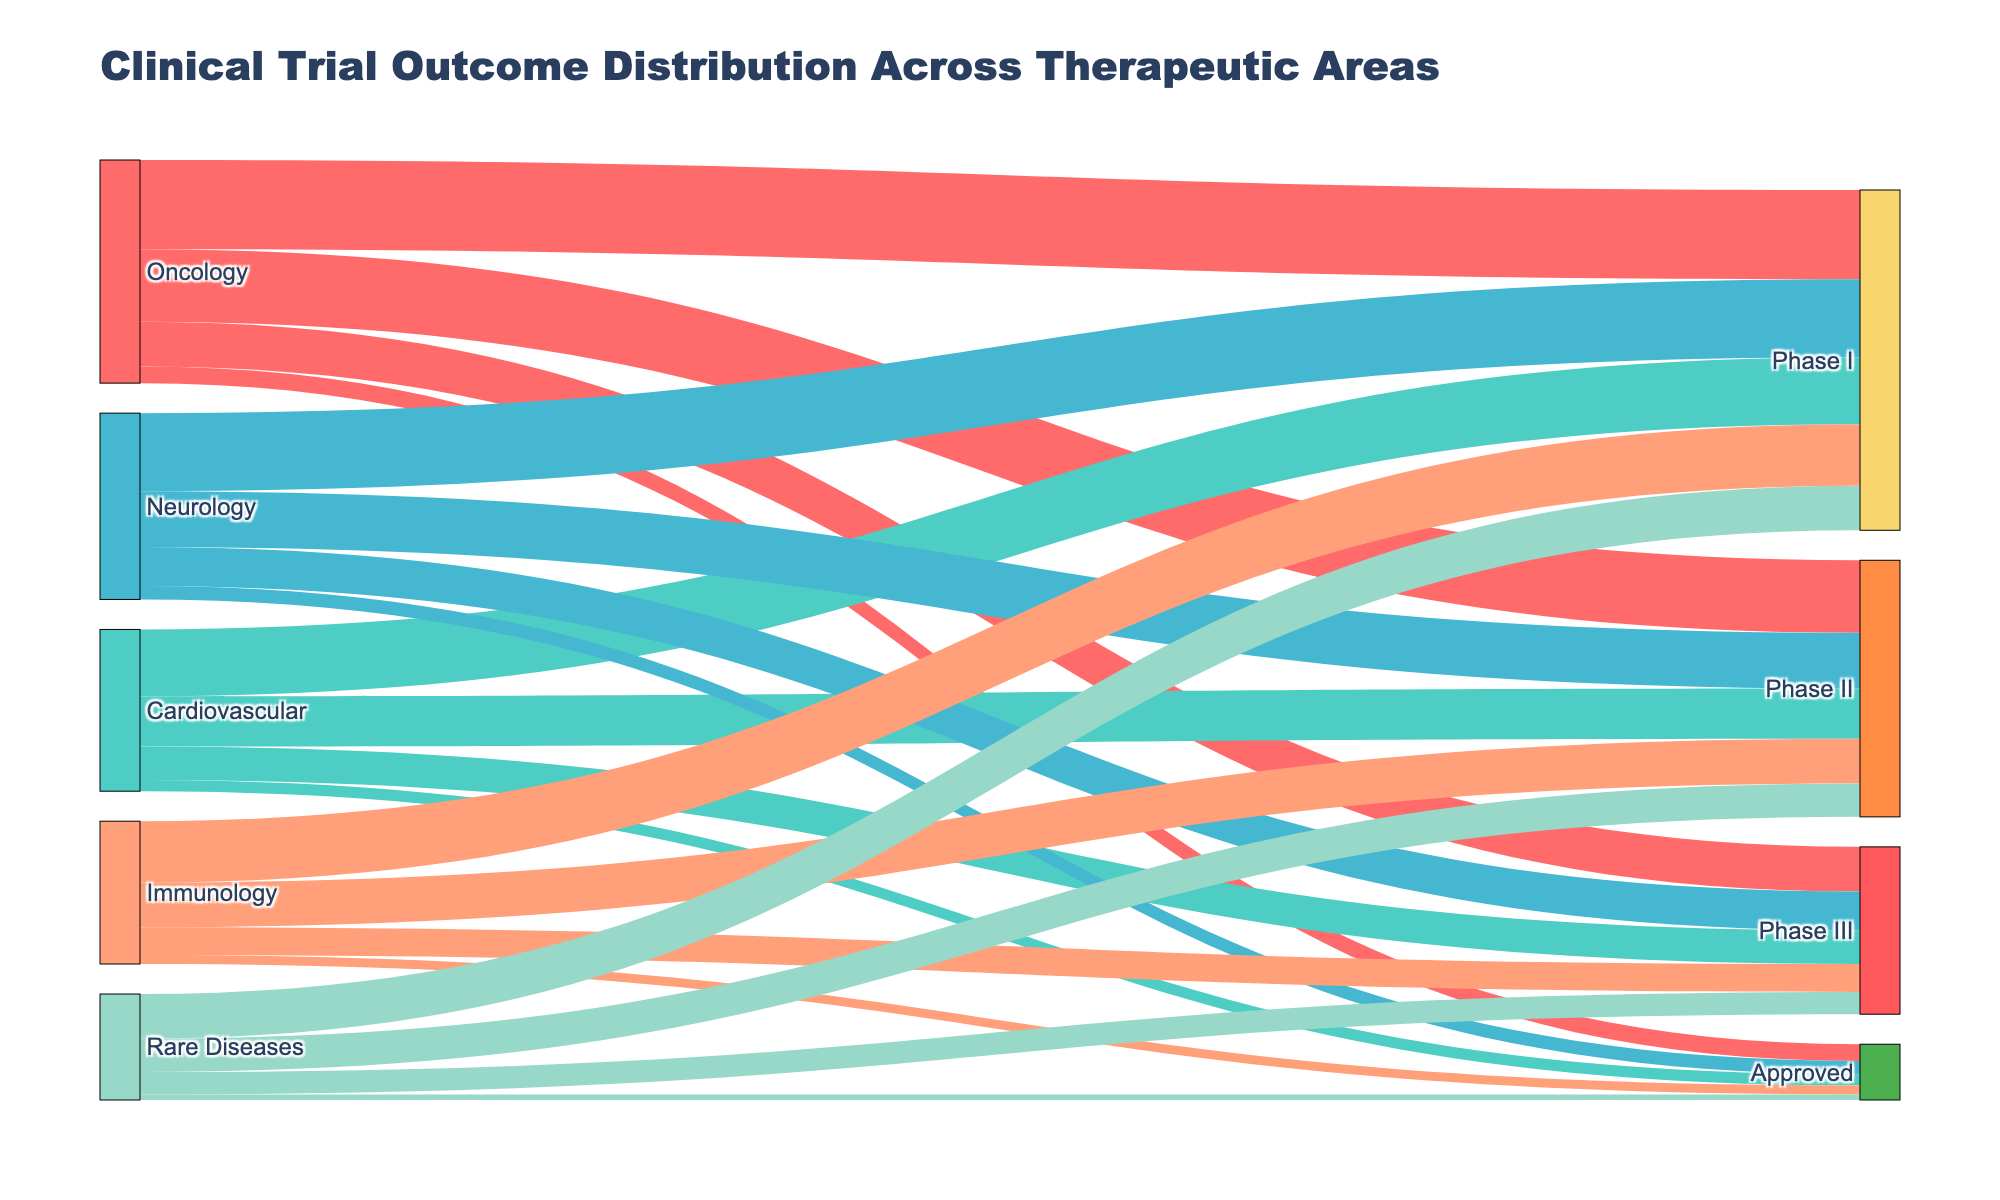What is the title of the figure? The title of the figure is prominently displayed at the top of the chart. It reads "Clinical Trial Outcome Distribution Across Therapeutic Areas".
Answer: Clinical Trial Outcome Distribution Across Therapeutic Areas How many therapeutic areas are represented in the figure? The figure shows labels for all the therapeutic areas originating the flows. There are five therapeutic areas: Oncology, Cardiovascular, Neurology, Immunology, and Rare Diseases.
Answer: Five What color is used to represent Neurology? Each therapeutic area is represented by a unique color. The color used for Neurology is a shade of blue (#45B7D1).
Answer: Blue (#45B7D1) Which therapeutic area has the highest number of Phase I trials? Observing the links emanating from each therapeutic area to Phase I, the width of the link for Oncology extends the furthest, indicating it has the highest number of Phase I trials at 80.
Answer: Oncology What is the total number of Phase III trials across all therapeutic areas? Sum the values for Phase III trials from each therapeutic area: 40 (Oncology) + 30 (Cardiovascular) + 35 (Neurology) + 25 (Immunology) + 20 (Rare Diseases) = 150.
Answer: 150 What is the difference in the number of Phase I and Phase II trials in Cardiovascular? Subtract the value of Phase II trials from Phase I trials in Cardiovascular: 60 (Phase I) - 45 (Phase II) = 15.
Answer: 15 Which therapeutic area has the least number of trials in the Approved phase? By examining the flows leading to the Approved phase, Rare Diseases has the least number with 5 trials.
Answer: Rare Diseases Compare the number of Approved trials between Neurology and Immunology. Which one has more, and by how much? Neurology has 12 Approved trials, whereas Immunology has 8. The difference is 12 - 8 = 4, so Neurology has 4 more Approved trials than Immunology.
Answer: Neurology by 4 How many therapeutic areas have more than 50 trials in Phase I? Oncology (80), Neurology (70), and Cardiovascular (60) all have more than 50 trials in Phase I. Immunology (55) also has more than 50. Hence, there are four therapeutic areas.
Answer: Four Which phase in Oncology has the biggest drop in the number of trials when moving to the next phase? Comparing the values between phases in Oncology, the biggest drop is from Phase II (65) to Phase III (40), which is a difference of 65 - 40 = 25.
Answer: Phase II to Phase III 